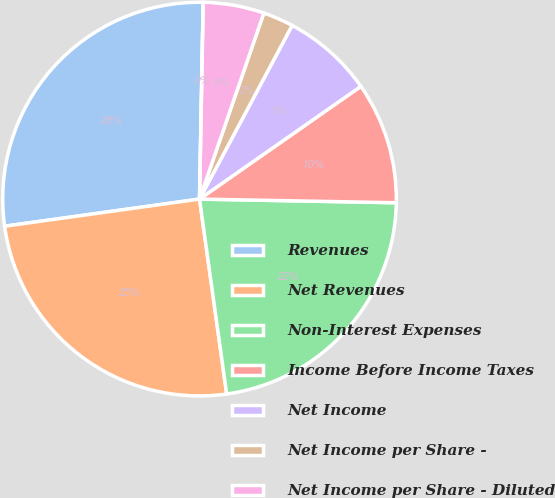Convert chart to OTSL. <chart><loc_0><loc_0><loc_500><loc_500><pie_chart><fcel>Revenues<fcel>Net Revenues<fcel>Non-Interest Expenses<fcel>Income Before Income Taxes<fcel>Net Income<fcel>Net Income per Share -<fcel>Net Income per Share - Diluted<fcel>Dividends Declared per Share<nl><fcel>27.5%<fcel>25.0%<fcel>22.5%<fcel>10.0%<fcel>7.5%<fcel>2.5%<fcel>5.0%<fcel>0.0%<nl></chart> 